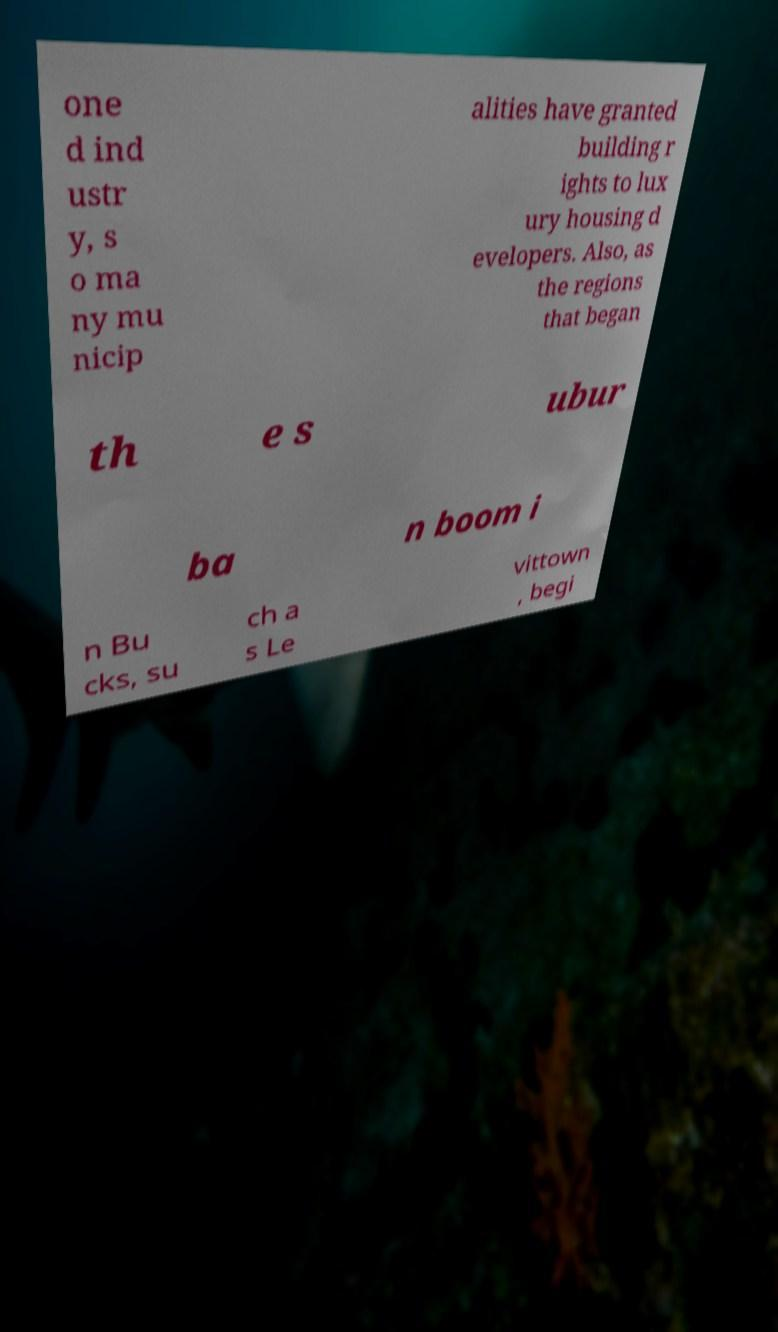For documentation purposes, I need the text within this image transcribed. Could you provide that? one d ind ustr y, s o ma ny mu nicip alities have granted building r ights to lux ury housing d evelopers. Also, as the regions that began th e s ubur ba n boom i n Bu cks, su ch a s Le vittown , begi 